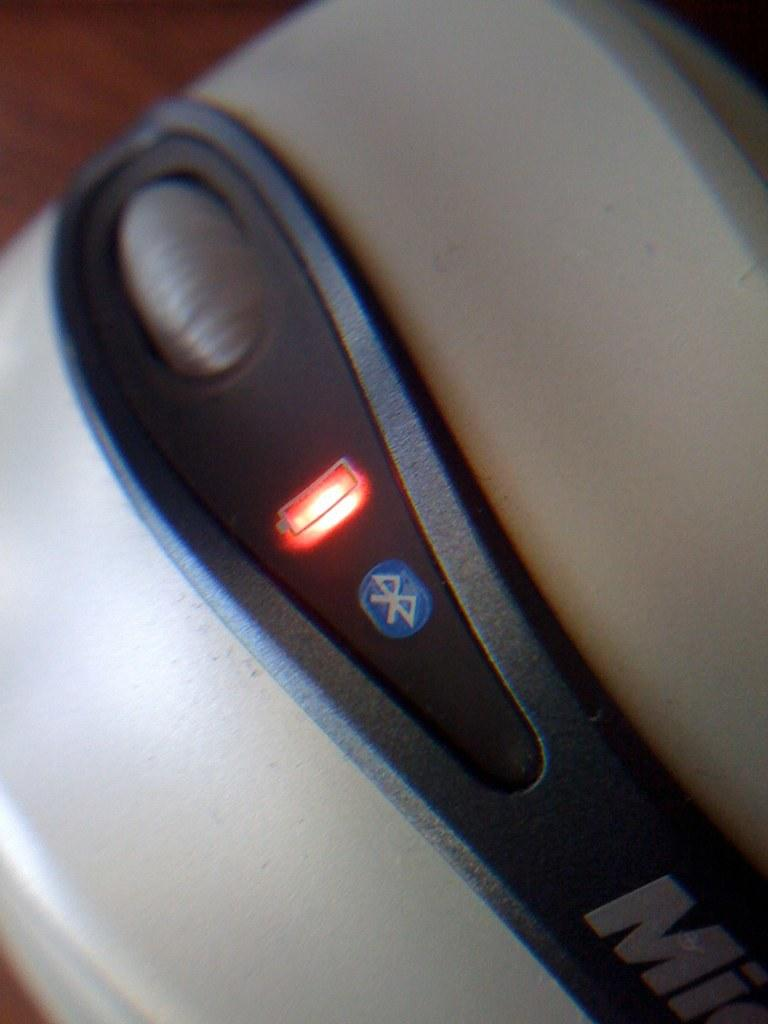What type of animal is present in the image? There is a mouse in the image. Does the mouse have any special features or connections? Yes, the mouse has a Bluetooth connection. How does the mouse help with pump maintenance in the image? There is no pump present in the image, and the mouse is not shown assisting with any maintenance tasks. 